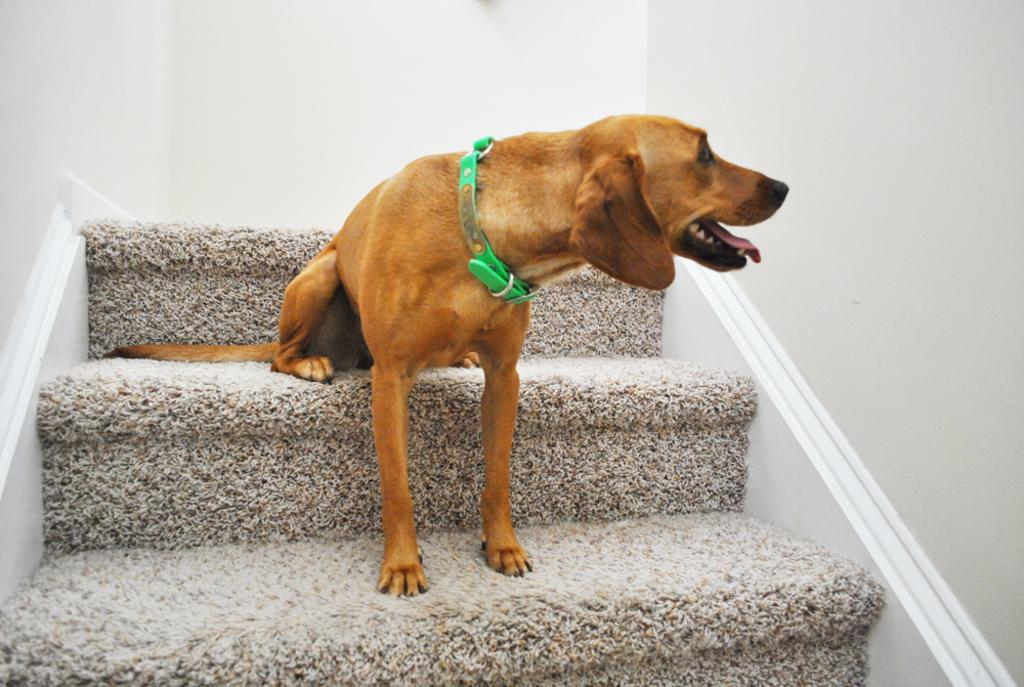What is the main subject in the foreground of the image? There is a dog in the foreground of the image. What is the dog doing in the image? The dog is sitting on the stairs. What can be seen on either side and in the background of the image? There is a white wall on either side and in the background of the image. Can you see the dog's toe in the image? There is no specific focus on the dog's toe in the image, so it cannot be determined if it is visible or not. 